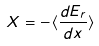Convert formula to latex. <formula><loc_0><loc_0><loc_500><loc_500>X = - \langle \frac { d E _ { r } } { d x } \rangle</formula> 